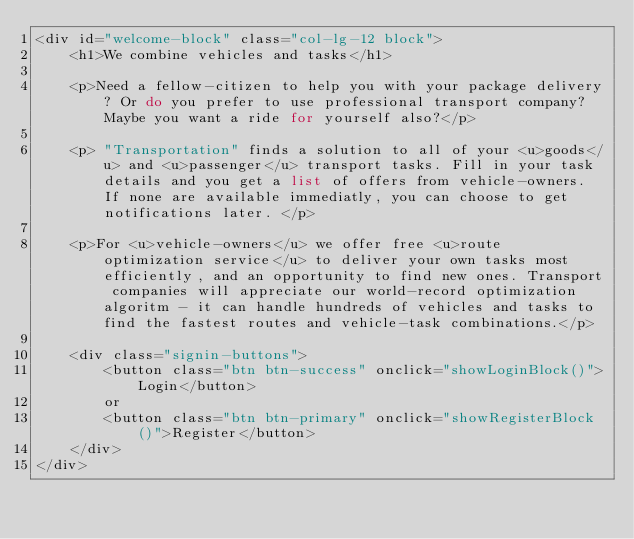Convert code to text. <code><loc_0><loc_0><loc_500><loc_500><_PHP_><div id="welcome-block" class="col-lg-12 block">
    <h1>We combine vehicles and tasks</h1>

    <p>Need a fellow-citizen to help you with your package delivery? Or do you prefer to use professional transport company? Maybe you want a ride for yourself also?</p>

    <p> "Transportation" finds a solution to all of your <u>goods</u> and <u>passenger</u> transport tasks. Fill in your task details and you get a list of offers from vehicle-owners. If none are available immediatly, you can choose to get notifications later. </p>

    <p>For <u>vehicle-owners</u> we offer free <u>route optimization service</u> to deliver your own tasks most efficiently, and an opportunity to find new ones. Transport companies will appreciate our world-record optimization algoritm - it can handle hundreds of vehicles and tasks to find the fastest routes and vehicle-task combinations.</p>

    <div class="signin-buttons">
        <button class="btn btn-success" onclick="showLoginBlock()">Login</button>
        or
        <button class="btn btn-primary" onclick="showRegisterBlock()">Register</button>
    </div>
</div></code> 